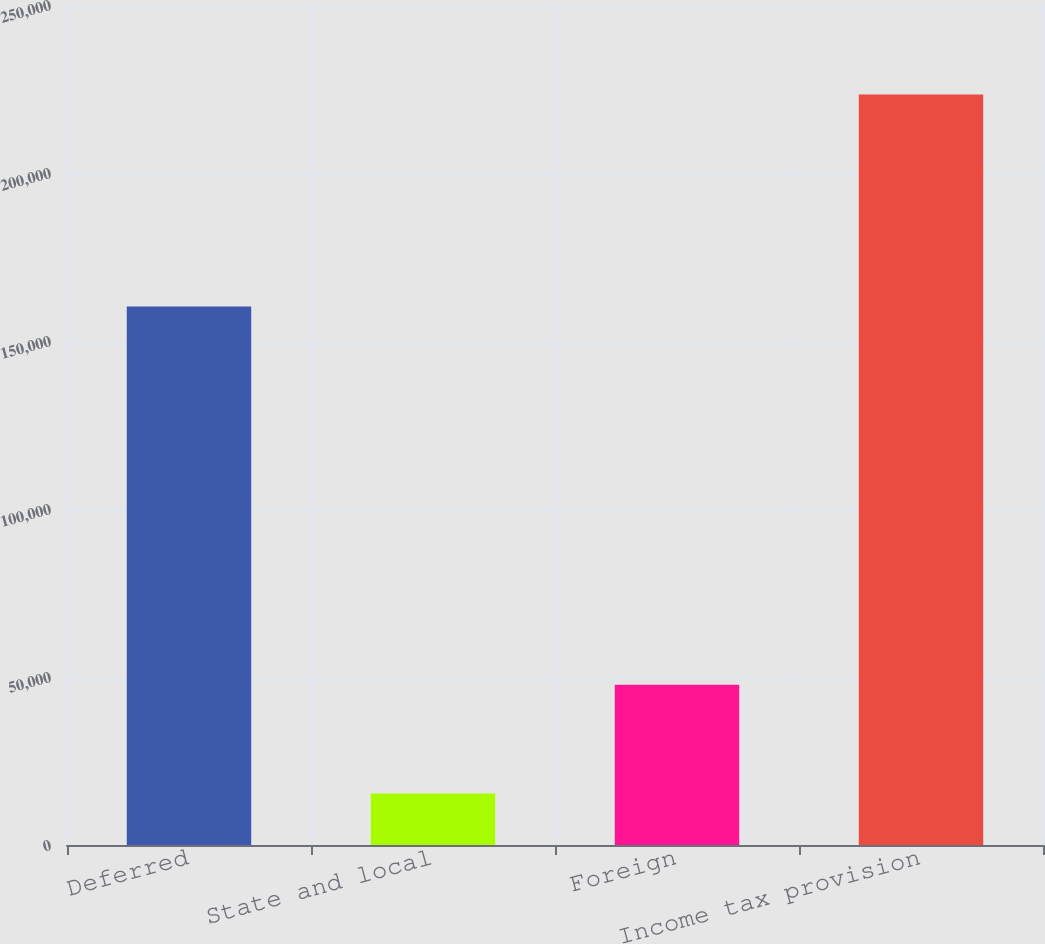Convert chart to OTSL. <chart><loc_0><loc_0><loc_500><loc_500><bar_chart><fcel>Deferred<fcel>State and local<fcel>Foreign<fcel>Income tax provision<nl><fcel>160302<fcel>15315<fcel>47710<fcel>223327<nl></chart> 